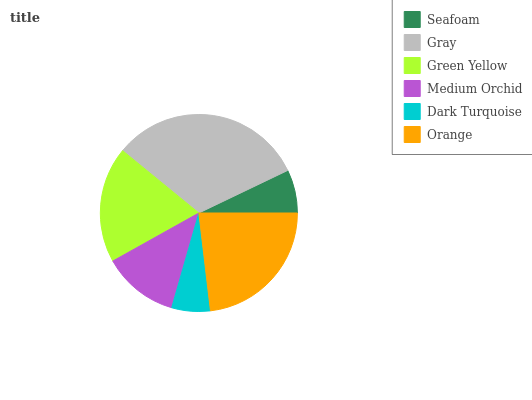Is Dark Turquoise the minimum?
Answer yes or no. Yes. Is Gray the maximum?
Answer yes or no. Yes. Is Green Yellow the minimum?
Answer yes or no. No. Is Green Yellow the maximum?
Answer yes or no. No. Is Gray greater than Green Yellow?
Answer yes or no. Yes. Is Green Yellow less than Gray?
Answer yes or no. Yes. Is Green Yellow greater than Gray?
Answer yes or no. No. Is Gray less than Green Yellow?
Answer yes or no. No. Is Green Yellow the high median?
Answer yes or no. Yes. Is Medium Orchid the low median?
Answer yes or no. Yes. Is Orange the high median?
Answer yes or no. No. Is Orange the low median?
Answer yes or no. No. 